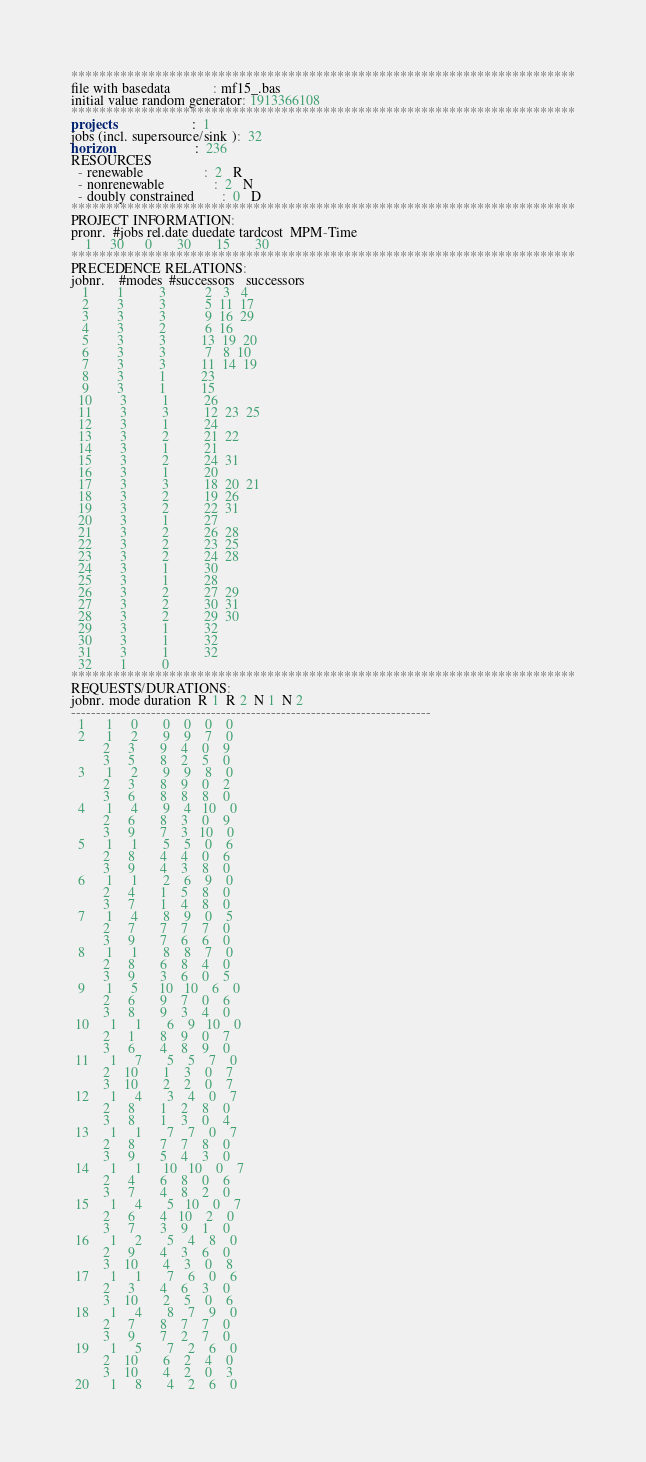<code> <loc_0><loc_0><loc_500><loc_500><_ObjectiveC_>************************************************************************
file with basedata            : mf15_.bas
initial value random generator: 1913366108
************************************************************************
projects                      :  1
jobs (incl. supersource/sink ):  32
horizon                       :  236
RESOURCES
  - renewable                 :  2   R
  - nonrenewable              :  2   N
  - doubly constrained        :  0   D
************************************************************************
PROJECT INFORMATION:
pronr.  #jobs rel.date duedate tardcost  MPM-Time
    1     30      0       30       15       30
************************************************************************
PRECEDENCE RELATIONS:
jobnr.    #modes  #successors   successors
   1        1          3           2   3   4
   2        3          3           5  11  17
   3        3          3           9  16  29
   4        3          2           6  16
   5        3          3          13  19  20
   6        3          3           7   8  10
   7        3          3          11  14  19
   8        3          1          23
   9        3          1          15
  10        3          1          26
  11        3          3          12  23  25
  12        3          1          24
  13        3          2          21  22
  14        3          1          21
  15        3          2          24  31
  16        3          1          20
  17        3          3          18  20  21
  18        3          2          19  26
  19        3          2          22  31
  20        3          1          27
  21        3          2          26  28
  22        3          2          23  25
  23        3          2          24  28
  24        3          1          30
  25        3          1          28
  26        3          2          27  29
  27        3          2          30  31
  28        3          2          29  30
  29        3          1          32
  30        3          1          32
  31        3          1          32
  32        1          0        
************************************************************************
REQUESTS/DURATIONS:
jobnr. mode duration  R 1  R 2  N 1  N 2
------------------------------------------------------------------------
  1      1     0       0    0    0    0
  2      1     2       9    9    7    0
         2     3       9    4    0    9
         3     5       8    2    5    0
  3      1     2       9    9    8    0
         2     3       8    9    0    2
         3     6       8    8    8    0
  4      1     4       9    4   10    0
         2     6       8    3    0    9
         3     9       7    3   10    0
  5      1     1       5    5    0    6
         2     8       4    4    0    6
         3     9       4    3    8    0
  6      1     1       2    6    9    0
         2     4       1    5    8    0
         3     7       1    4    8    0
  7      1     4       8    9    0    5
         2     7       7    7    7    0
         3     9       7    6    6    0
  8      1     1       8    8    7    0
         2     8       6    8    4    0
         3     9       3    6    0    5
  9      1     5      10   10    6    0
         2     6       9    7    0    6
         3     8       9    3    4    0
 10      1     1       6    9   10    0
         2     1       8    9    0    7
         3     6       4    8    9    0
 11      1     7       5    5    7    0
         2    10       1    3    0    7
         3    10       2    2    0    7
 12      1     4       3    4    0    7
         2     8       1    2    8    0
         3     8       1    3    0    4
 13      1     1       7    7    0    7
         2     8       7    7    8    0
         3     9       5    4    3    0
 14      1     1      10   10    0    7
         2     4       6    8    0    6
         3     7       4    8    2    0
 15      1     4       5   10    0    7
         2     6       4   10    2    0
         3     7       3    9    1    0
 16      1     2       5    4    8    0
         2     9       4    3    6    0
         3    10       4    3    0    8
 17      1     1       7    6    0    6
         2     3       4    6    3    0
         3    10       2    5    0    6
 18      1     4       8    7    9    0
         2     7       8    7    7    0
         3     9       7    2    7    0
 19      1     5       7    2    6    0
         2    10       6    2    4    0
         3    10       4    2    0    3
 20      1     8       4    2    6    0</code> 